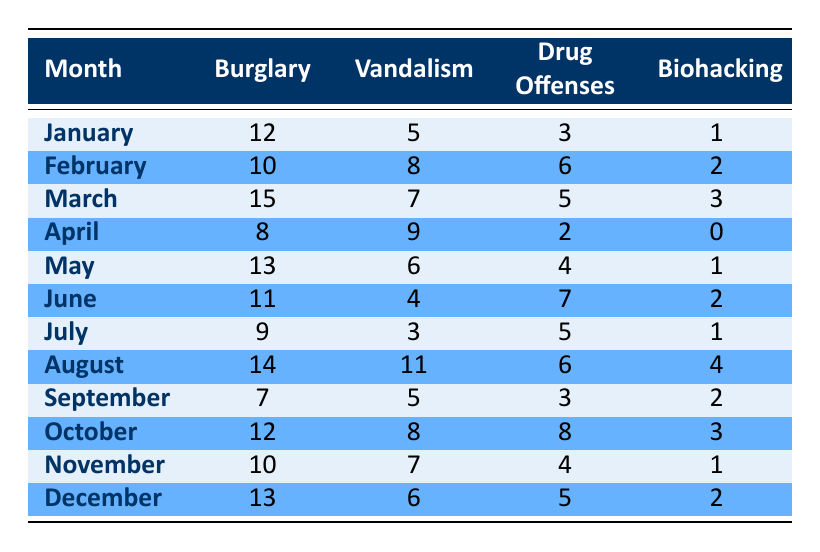What month had the highest number of burglaries? By examining the table, the highest number of burglaries is found in March, with a total of 15 reported.
Answer: March What was the total number of biohacking incidents reported from January to April? The incidents for each month from January to April are 1, 2, 3, and 0 respectively. Summing these gives us 1 + 2 + 3 + 0 = 6.
Answer: 6 Is there a month where vandalism was higher than drug offenses? To confirm, we compare the values: January (5 vs 3), February (8 vs 6), March (7 vs 5), April (9 vs 2), May (6 vs 4), June (4 vs 7), July (3 vs 5), August (11 vs 6), September (5 vs 3), October (8 vs 8), November (7 vs 4), December (6 vs 5). Vandalism is higher in 9 out of 12 months. Thus, the statement is true.
Answer: Yes What is the average number of drug offenses reported across the year? The total number of drug offenses is 3 + 6 + 5 + 2 + 4 + 7 + 5 + 6 + 3 + 8 + 4 + 5 = 66. There are 12 months in total, so we calculate the average: 66 / 12 = 5.5.
Answer: 5.5 Which month had the least number of biohacking activities? Observing the table, April reports 0 incidents, which is the lowest for biohacking.
Answer: April 